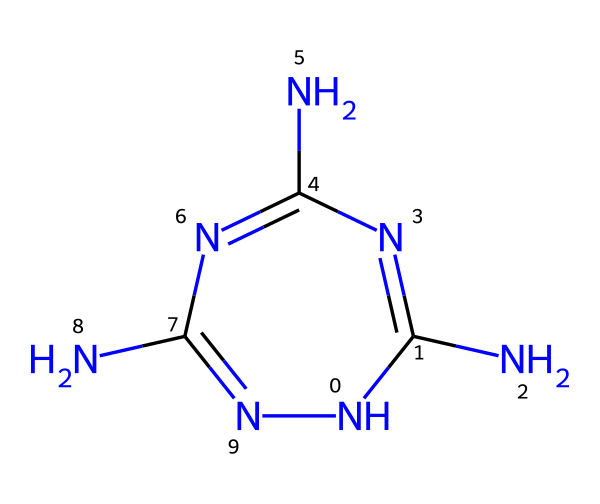What is the primary element present in melamine? The structure of melamine primarily consists of nitrogen (N) and carbon (C) atoms. However, a quick count shows that nitrogen is the most prevalent in this particular structure.
Answer: nitrogen How many nitrogen atoms are in the structure? By analyzing the SMILES representation, there are four nitrogen atoms (indicated by the 'N' symbols) connected in a cyclic fashion, which is visible in the structure.
Answer: four What type of chemical structure does melamine represent? Melamine represents a triazine structure due to the arrangement of three nitrogen atoms in a six-membered ring with carbon atoms, categorized as a nitrogen-rich heterocycle.
Answer: triazine How many total atoms are present in the structure? The SMILES structure includes 6 total atoms: 4 nitrogen and 2 carbon. Adding them gives a total of 6 atoms.
Answer: six What functional group is characteristic of melamine? The structure shows multiple amine (-NH) groups, indicative of its classification as an amine compound, which is characteristic of melamine.
Answer: amine What is the molecular formula of melamine? From the structure, we derive the molecular formula as C3H6N6, comprising 3 carbon atoms, 6 hydrogen atoms, and 6 nitrogen atoms.
Answer: C3H6N6 